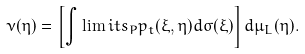<formula> <loc_0><loc_0><loc_500><loc_500>\nu ( \eta ) = \left [ \int \lim i t s _ { P } p _ { t } ( \xi , \eta ) d \sigma ( \xi ) \right ] d \mu _ { L } ( \eta ) .</formula> 